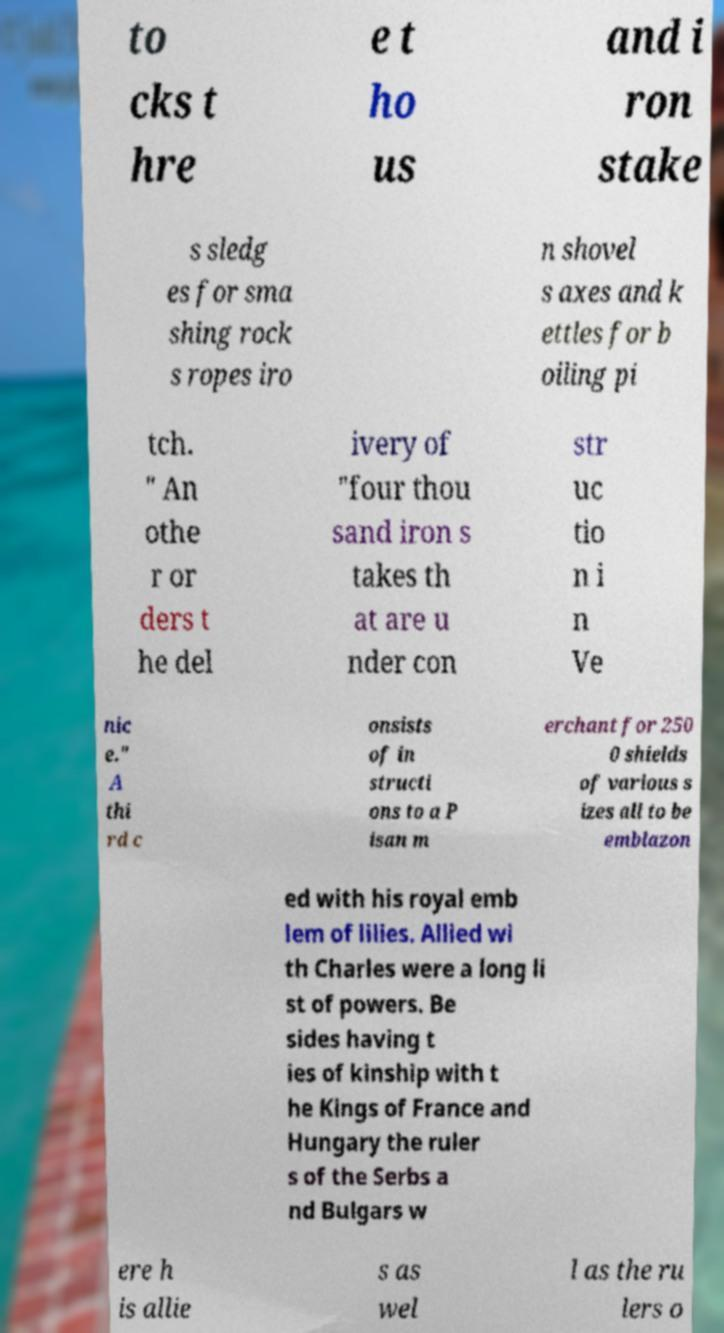Could you assist in decoding the text presented in this image and type it out clearly? to cks t hre e t ho us and i ron stake s sledg es for sma shing rock s ropes iro n shovel s axes and k ettles for b oiling pi tch. " An othe r or ders t he del ivery of "four thou sand iron s takes th at are u nder con str uc tio n i n Ve nic e." A thi rd c onsists of in structi ons to a P isan m erchant for 250 0 shields of various s izes all to be emblazon ed with his royal emb lem of lilies. Allied wi th Charles were a long li st of powers. Be sides having t ies of kinship with t he Kings of France and Hungary the ruler s of the Serbs a nd Bulgars w ere h is allie s as wel l as the ru lers o 